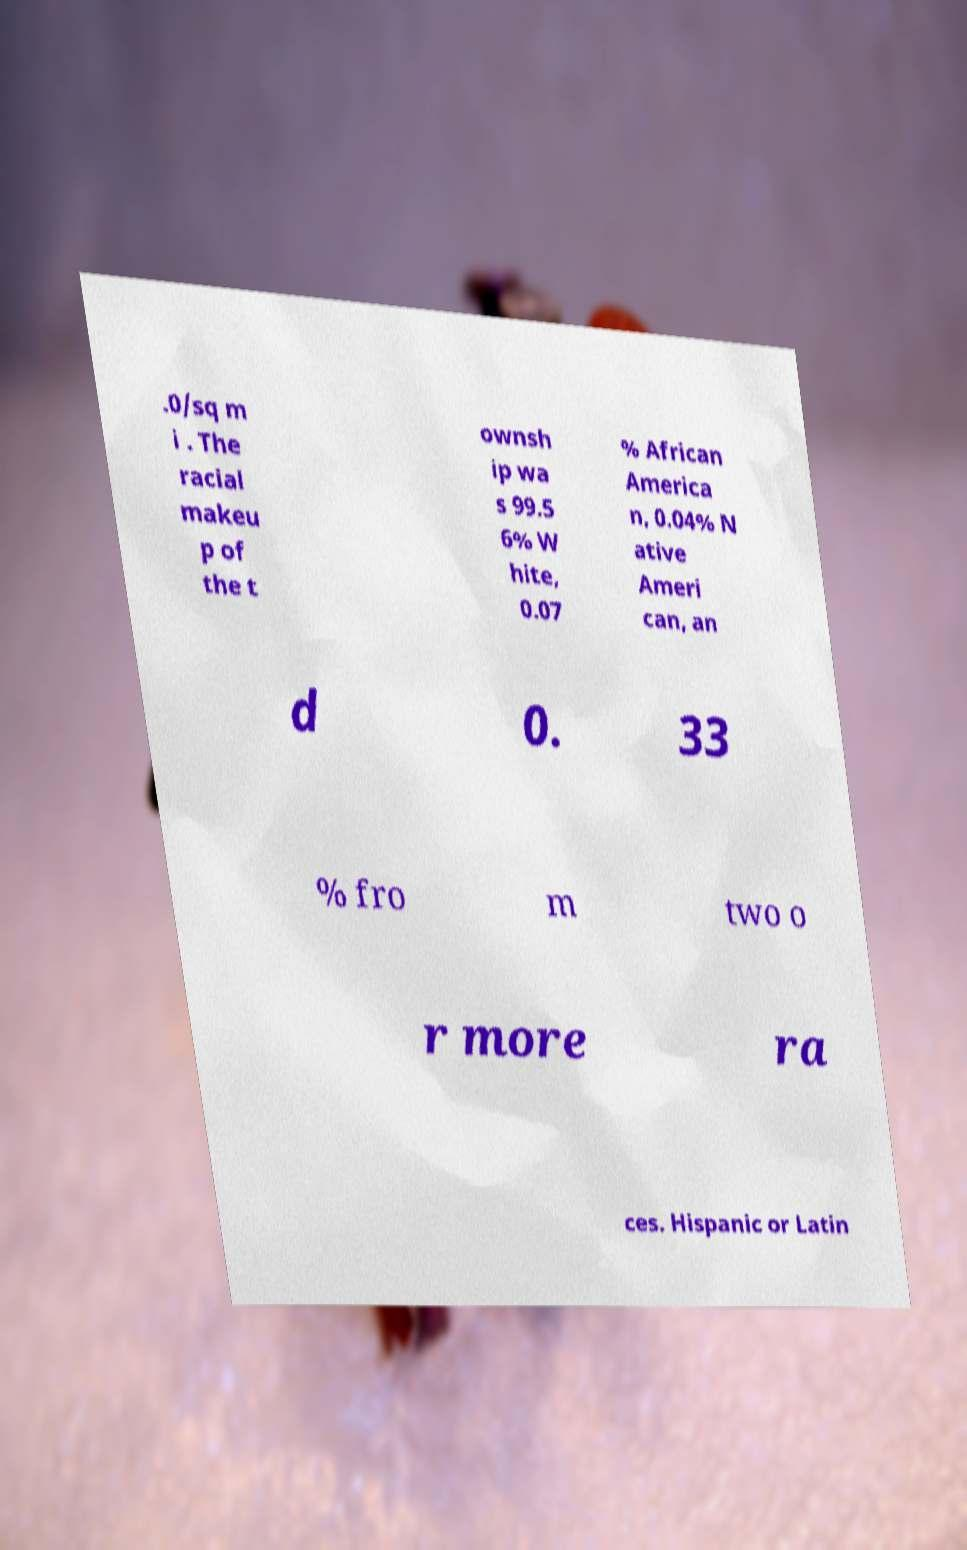Can you read and provide the text displayed in the image?This photo seems to have some interesting text. Can you extract and type it out for me? .0/sq m i . The racial makeu p of the t ownsh ip wa s 99.5 6% W hite, 0.07 % African America n, 0.04% N ative Ameri can, an d 0. 33 % fro m two o r more ra ces. Hispanic or Latin 